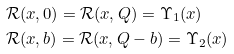<formula> <loc_0><loc_0><loc_500><loc_500>& \mathcal { R } ( x , 0 ) = \mathcal { R } ( x , Q ) = \Upsilon _ { 1 } ( x ) \\ & \mathcal { R } ( x , b ) = \mathcal { R } ( x , Q - b ) = \Upsilon _ { 2 } ( x )</formula> 